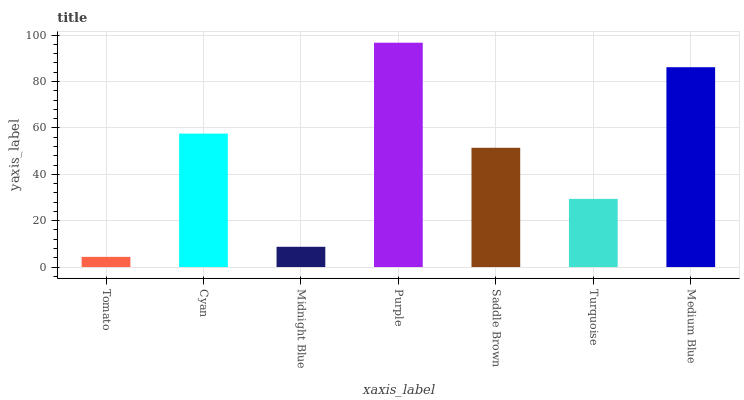Is Cyan the minimum?
Answer yes or no. No. Is Cyan the maximum?
Answer yes or no. No. Is Cyan greater than Tomato?
Answer yes or no. Yes. Is Tomato less than Cyan?
Answer yes or no. Yes. Is Tomato greater than Cyan?
Answer yes or no. No. Is Cyan less than Tomato?
Answer yes or no. No. Is Saddle Brown the high median?
Answer yes or no. Yes. Is Saddle Brown the low median?
Answer yes or no. Yes. Is Turquoise the high median?
Answer yes or no. No. Is Tomato the low median?
Answer yes or no. No. 